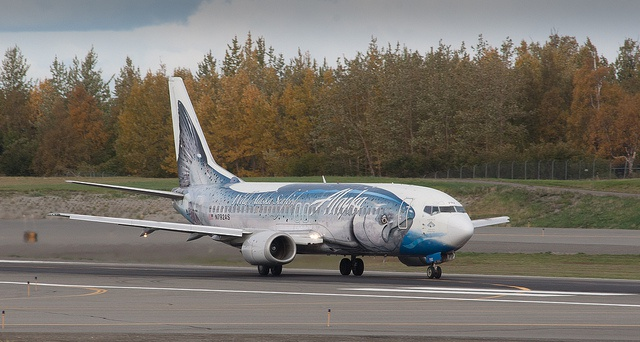Describe the objects in this image and their specific colors. I can see a airplane in gray, darkgray, lightgray, and black tones in this image. 